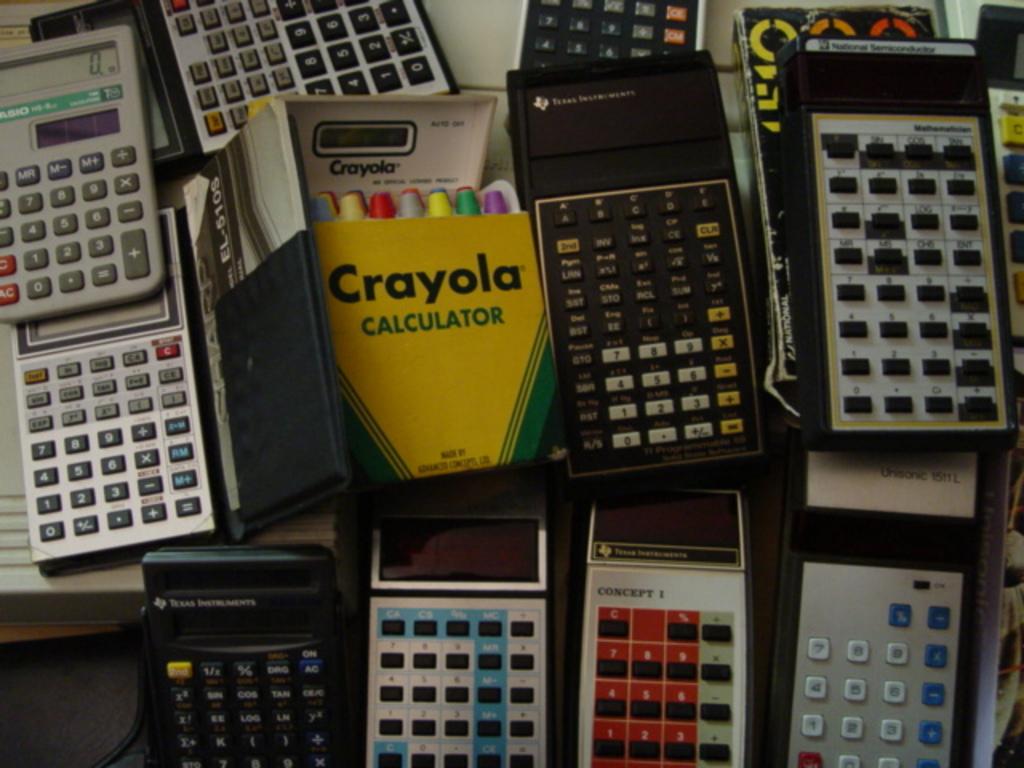What brand is the colorful box?
Your answer should be very brief. Crayola. Is there a concept 1 calculator at the bottom?
Your answer should be very brief. Yes. 